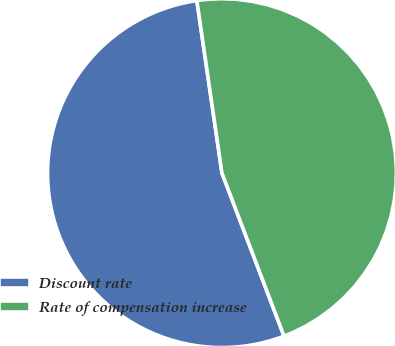<chart> <loc_0><loc_0><loc_500><loc_500><pie_chart><fcel>Discount rate<fcel>Rate of compensation increase<nl><fcel>53.49%<fcel>46.51%<nl></chart> 